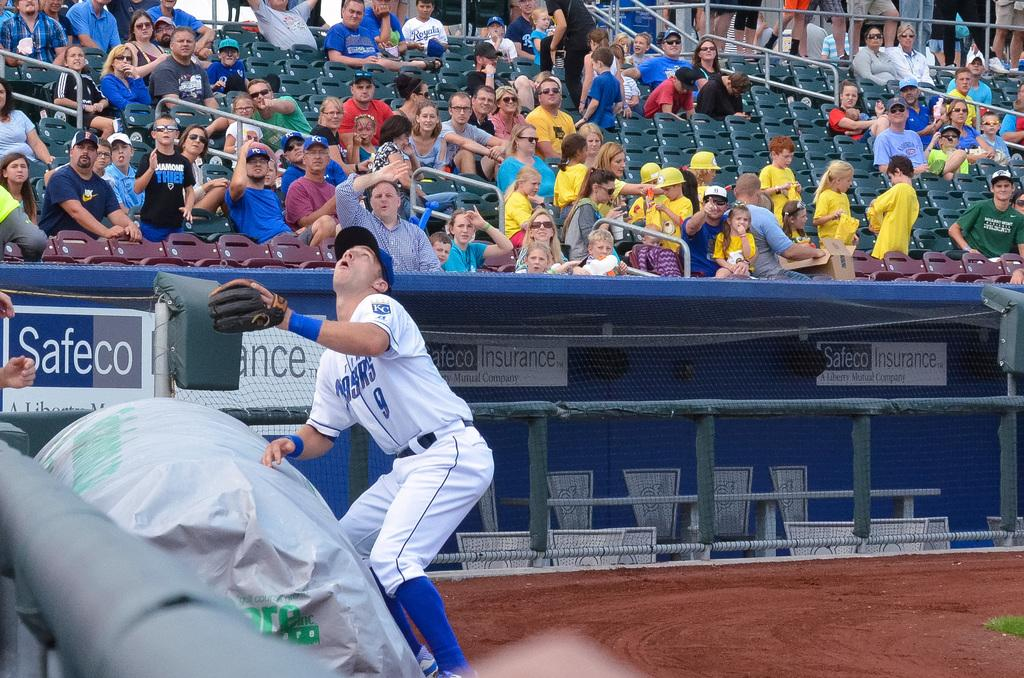How many people are in the image? There is a group of people in the image. What are the people sitting on? The people are sitting on green chairs. What is in front of the people? There is a net fencing and some objects visible in front of the people. Can you describe the clothing of one person in the group? One person in the group is wearing a white and blue color dress. How much dirt is visible on the green chairs in the image? There is no dirt visible on the green chairs in the image. What type of calculator is being used by the person in the white and blue dress? There is no calculator present in the image. 